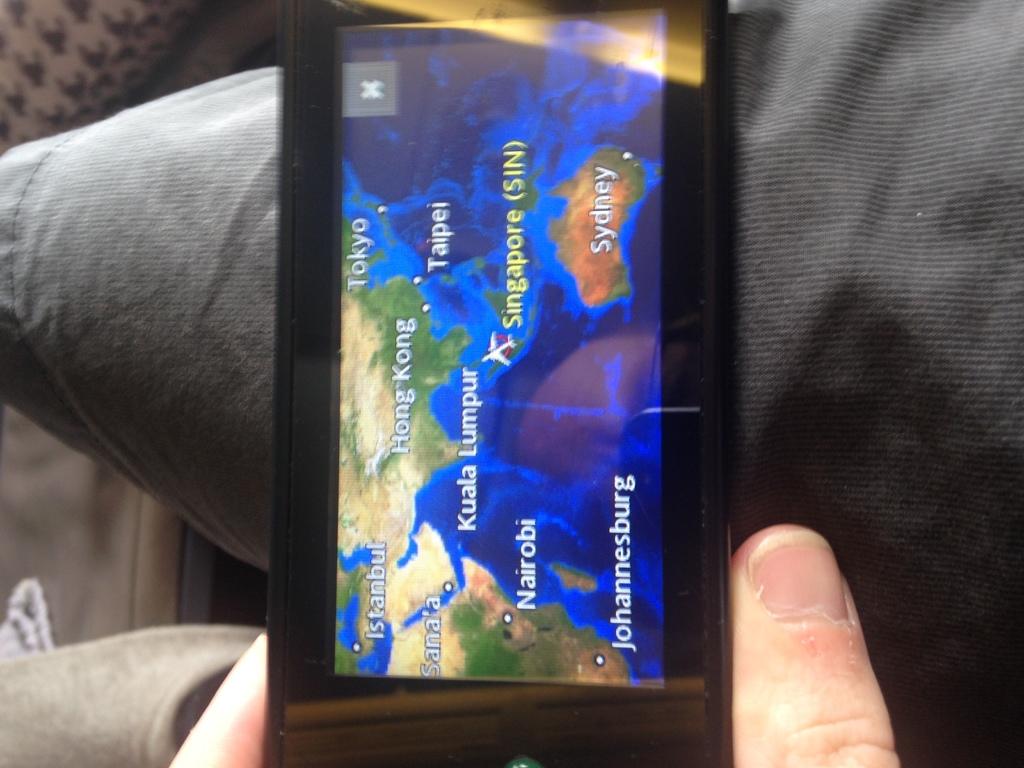What city is in the bottom left?
Give a very brief answer. Johannesburg. What city is on the bottom right of the map?
Provide a succinct answer. Sydney. 